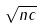Convert formula to latex. <formula><loc_0><loc_0><loc_500><loc_500>\sqrt { n c }</formula> 